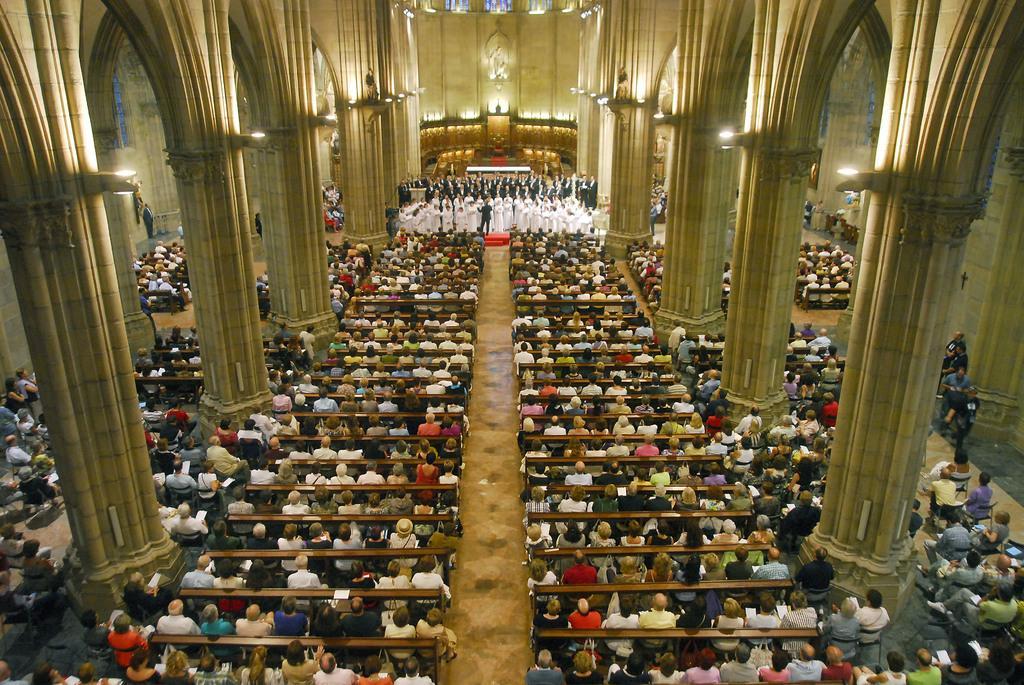Describe this image in one or two sentences. In this image there are persons sitting and standing, there are pillars and there are lights. 